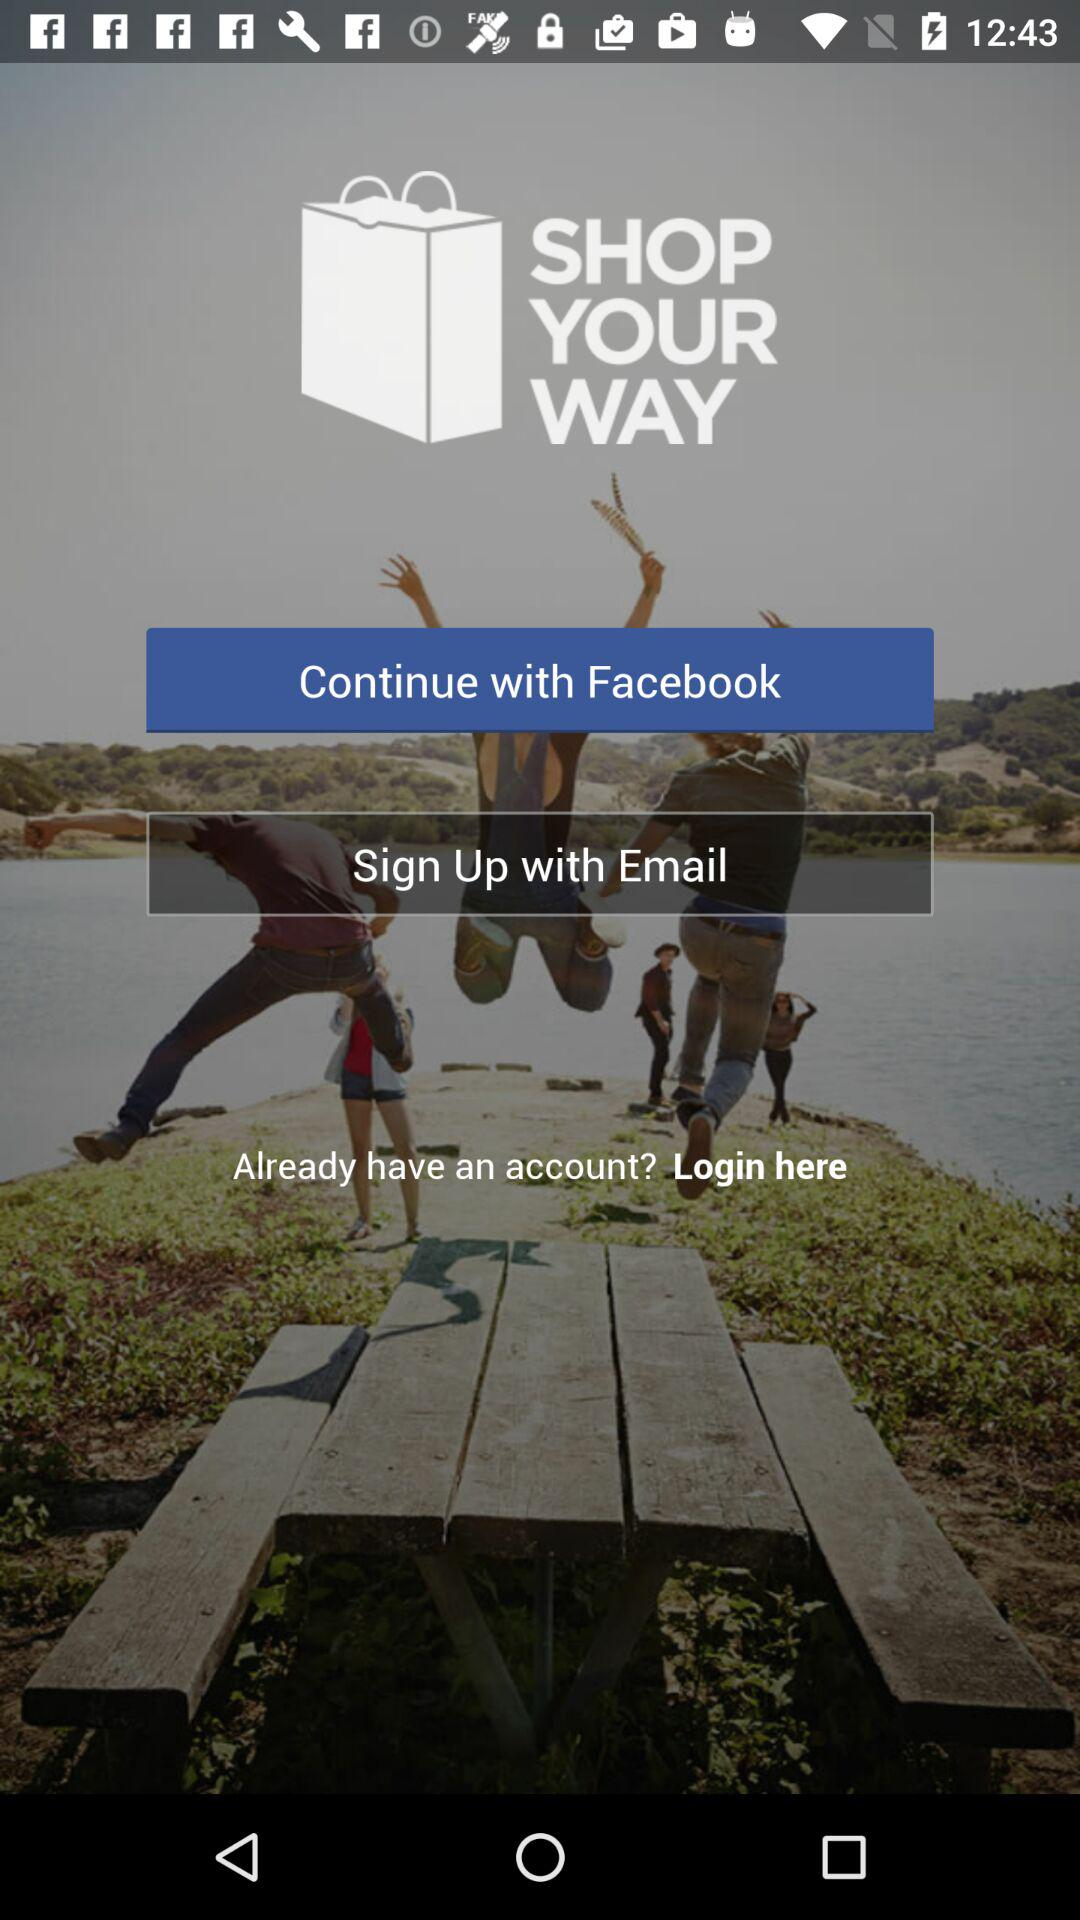How can we continue? You can continue with "Facebook". 